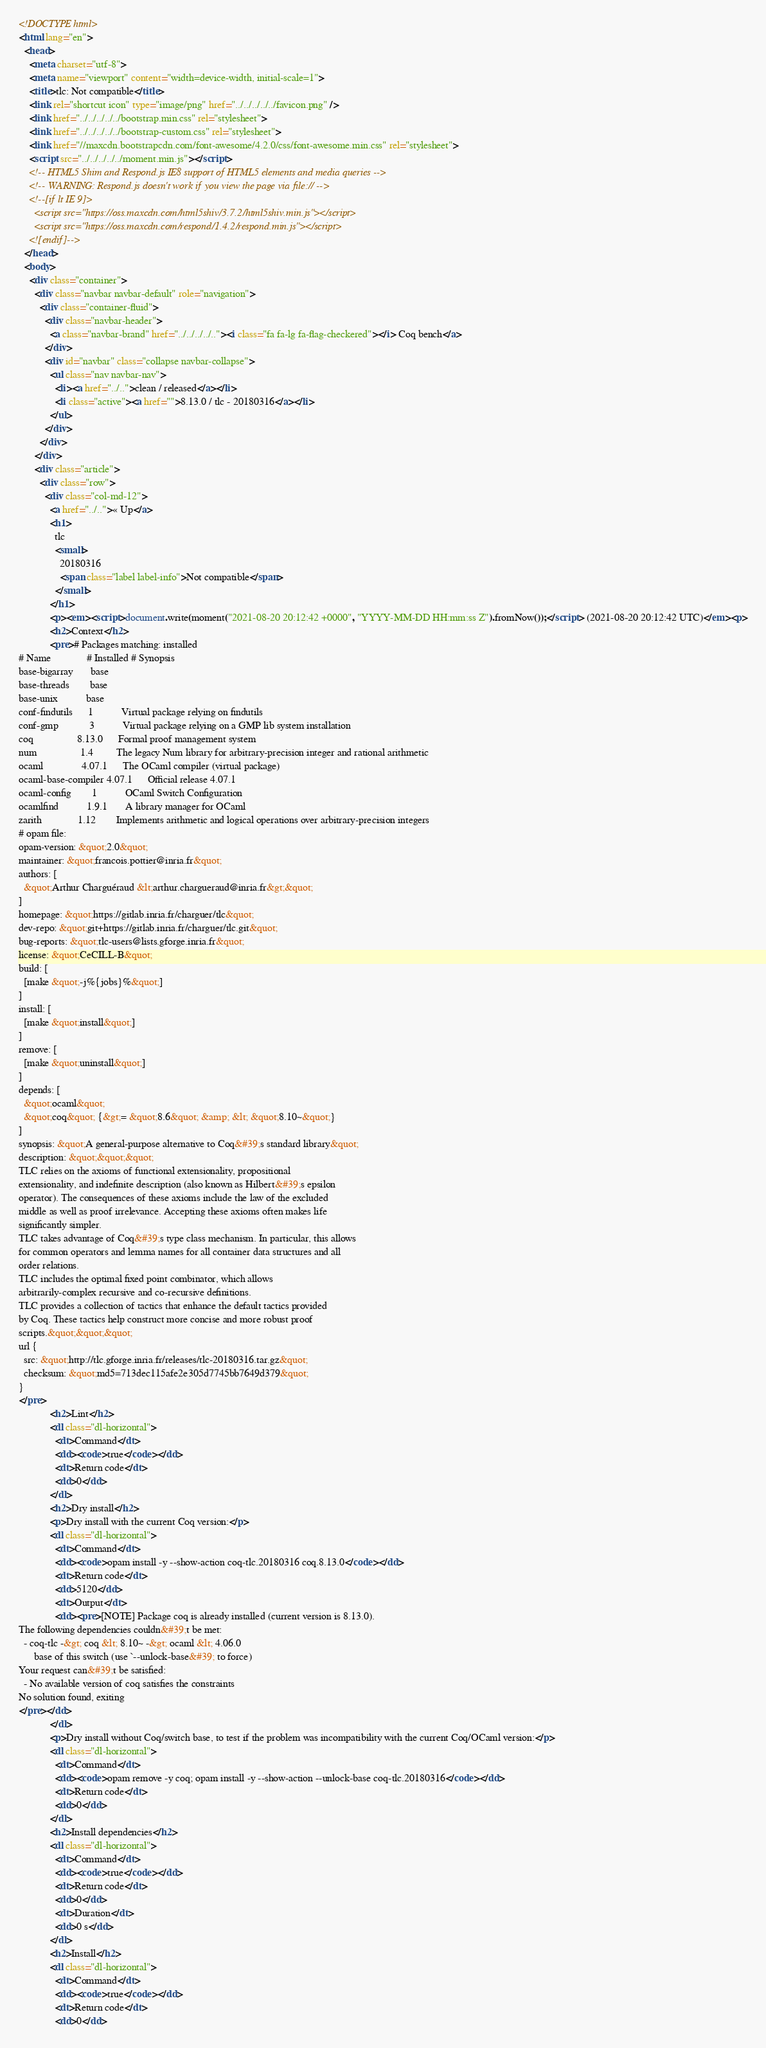Convert code to text. <code><loc_0><loc_0><loc_500><loc_500><_HTML_><!DOCTYPE html>
<html lang="en">
  <head>
    <meta charset="utf-8">
    <meta name="viewport" content="width=device-width, initial-scale=1">
    <title>tlc: Not compatible</title>
    <link rel="shortcut icon" type="image/png" href="../../../../../favicon.png" />
    <link href="../../../../../bootstrap.min.css" rel="stylesheet">
    <link href="../../../../../bootstrap-custom.css" rel="stylesheet">
    <link href="//maxcdn.bootstrapcdn.com/font-awesome/4.2.0/css/font-awesome.min.css" rel="stylesheet">
    <script src="../../../../../moment.min.js"></script>
    <!-- HTML5 Shim and Respond.js IE8 support of HTML5 elements and media queries -->
    <!-- WARNING: Respond.js doesn't work if you view the page via file:// -->
    <!--[if lt IE 9]>
      <script src="https://oss.maxcdn.com/html5shiv/3.7.2/html5shiv.min.js"></script>
      <script src="https://oss.maxcdn.com/respond/1.4.2/respond.min.js"></script>
    <![endif]-->
  </head>
  <body>
    <div class="container">
      <div class="navbar navbar-default" role="navigation">
        <div class="container-fluid">
          <div class="navbar-header">
            <a class="navbar-brand" href="../../../../.."><i class="fa fa-lg fa-flag-checkered"></i> Coq bench</a>
          </div>
          <div id="navbar" class="collapse navbar-collapse">
            <ul class="nav navbar-nav">
              <li><a href="../..">clean / released</a></li>
              <li class="active"><a href="">8.13.0 / tlc - 20180316</a></li>
            </ul>
          </div>
        </div>
      </div>
      <div class="article">
        <div class="row">
          <div class="col-md-12">
            <a href="../..">« Up</a>
            <h1>
              tlc
              <small>
                20180316
                <span class="label label-info">Not compatible</span>
              </small>
            </h1>
            <p><em><script>document.write(moment("2021-08-20 20:12:42 +0000", "YYYY-MM-DD HH:mm:ss Z").fromNow());</script> (2021-08-20 20:12:42 UTC)</em><p>
            <h2>Context</h2>
            <pre># Packages matching: installed
# Name              # Installed # Synopsis
base-bigarray       base
base-threads        base
base-unix           base
conf-findutils      1           Virtual package relying on findutils
conf-gmp            3           Virtual package relying on a GMP lib system installation
coq                 8.13.0      Formal proof management system
num                 1.4         The legacy Num library for arbitrary-precision integer and rational arithmetic
ocaml               4.07.1      The OCaml compiler (virtual package)
ocaml-base-compiler 4.07.1      Official release 4.07.1
ocaml-config        1           OCaml Switch Configuration
ocamlfind           1.9.1       A library manager for OCaml
zarith              1.12        Implements arithmetic and logical operations over arbitrary-precision integers
# opam file:
opam-version: &quot;2.0&quot;
maintainer: &quot;francois.pottier@inria.fr&quot;
authors: [
  &quot;Arthur Charguéraud &lt;arthur.chargueraud@inria.fr&gt;&quot;
]
homepage: &quot;https://gitlab.inria.fr/charguer/tlc&quot;
dev-repo: &quot;git+https://gitlab.inria.fr/charguer/tlc.git&quot;
bug-reports: &quot;tlc-users@lists.gforge.inria.fr&quot;
license: &quot;CeCILL-B&quot;
build: [
  [make &quot;-j%{jobs}%&quot;]
]
install: [
  [make &quot;install&quot;]
]
remove: [
  [make &quot;uninstall&quot;]
]
depends: [
  &quot;ocaml&quot;
  &quot;coq&quot; {&gt;= &quot;8.6&quot; &amp; &lt; &quot;8.10~&quot;}
]
synopsis: &quot;A general-purpose alternative to Coq&#39;s standard library&quot;
description: &quot;&quot;&quot;
TLC relies on the axioms of functional extensionality, propositional
extensionality, and indefinite description (also known as Hilbert&#39;s epsilon
operator). The consequences of these axioms include the law of the excluded
middle as well as proof irrelevance. Accepting these axioms often makes life
significantly simpler.
TLC takes advantage of Coq&#39;s type class mechanism. In particular, this allows
for common operators and lemma names for all container data structures and all
order relations.
TLC includes the optimal fixed point combinator, which allows
arbitrarily-complex recursive and co-recursive definitions.
TLC provides a collection of tactics that enhance the default tactics provided
by Coq. These tactics help construct more concise and more robust proof
scripts.&quot;&quot;&quot;
url {
  src: &quot;http://tlc.gforge.inria.fr/releases/tlc-20180316.tar.gz&quot;
  checksum: &quot;md5=713dec115afe2e305d7745bb7649d379&quot;
}
</pre>
            <h2>Lint</h2>
            <dl class="dl-horizontal">
              <dt>Command</dt>
              <dd><code>true</code></dd>
              <dt>Return code</dt>
              <dd>0</dd>
            </dl>
            <h2>Dry install</h2>
            <p>Dry install with the current Coq version:</p>
            <dl class="dl-horizontal">
              <dt>Command</dt>
              <dd><code>opam install -y --show-action coq-tlc.20180316 coq.8.13.0</code></dd>
              <dt>Return code</dt>
              <dd>5120</dd>
              <dt>Output</dt>
              <dd><pre>[NOTE] Package coq is already installed (current version is 8.13.0).
The following dependencies couldn&#39;t be met:
  - coq-tlc -&gt; coq &lt; 8.10~ -&gt; ocaml &lt; 4.06.0
      base of this switch (use `--unlock-base&#39; to force)
Your request can&#39;t be satisfied:
  - No available version of coq satisfies the constraints
No solution found, exiting
</pre></dd>
            </dl>
            <p>Dry install without Coq/switch base, to test if the problem was incompatibility with the current Coq/OCaml version:</p>
            <dl class="dl-horizontal">
              <dt>Command</dt>
              <dd><code>opam remove -y coq; opam install -y --show-action --unlock-base coq-tlc.20180316</code></dd>
              <dt>Return code</dt>
              <dd>0</dd>
            </dl>
            <h2>Install dependencies</h2>
            <dl class="dl-horizontal">
              <dt>Command</dt>
              <dd><code>true</code></dd>
              <dt>Return code</dt>
              <dd>0</dd>
              <dt>Duration</dt>
              <dd>0 s</dd>
            </dl>
            <h2>Install</h2>
            <dl class="dl-horizontal">
              <dt>Command</dt>
              <dd><code>true</code></dd>
              <dt>Return code</dt>
              <dd>0</dd></code> 